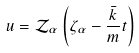Convert formula to latex. <formula><loc_0><loc_0><loc_500><loc_500>u = \mathcal { Z } _ { \alpha } \left ( \zeta _ { \alpha } - \frac { \bar { k } } { m } t \right )</formula> 